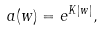<formula> <loc_0><loc_0><loc_500><loc_500>a ( w ) = e ^ { K | w | } ,</formula> 